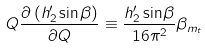Convert formula to latex. <formula><loc_0><loc_0><loc_500><loc_500>Q \frac { \partial \, ( h ^ { \prime } _ { 2 } \sin \beta ) } { \partial Q } \equiv \frac { h ^ { \prime } _ { 2 } \sin \beta } { 1 6 \pi ^ { 2 } } \beta _ { m _ { t } }</formula> 